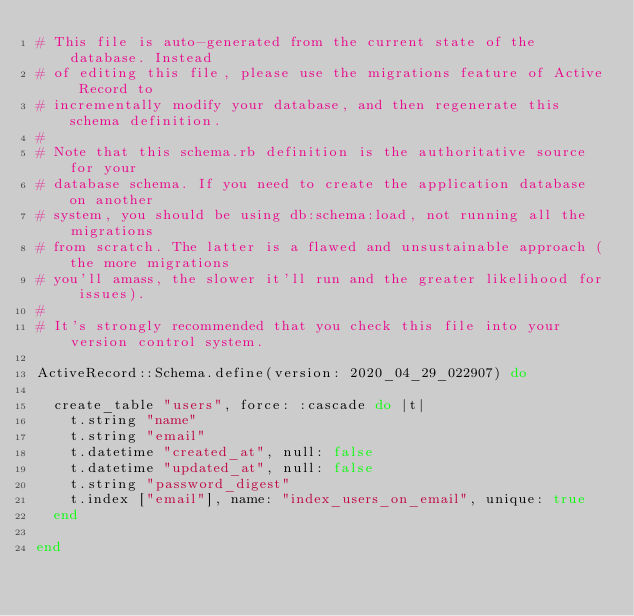Convert code to text. <code><loc_0><loc_0><loc_500><loc_500><_Ruby_># This file is auto-generated from the current state of the database. Instead
# of editing this file, please use the migrations feature of Active Record to
# incrementally modify your database, and then regenerate this schema definition.
#
# Note that this schema.rb definition is the authoritative source for your
# database schema. If you need to create the application database on another
# system, you should be using db:schema:load, not running all the migrations
# from scratch. The latter is a flawed and unsustainable approach (the more migrations
# you'll amass, the slower it'll run and the greater likelihood for issues).
#
# It's strongly recommended that you check this file into your version control system.

ActiveRecord::Schema.define(version: 2020_04_29_022907) do

  create_table "users", force: :cascade do |t|
    t.string "name"
    t.string "email"
    t.datetime "created_at", null: false
    t.datetime "updated_at", null: false
    t.string "password_digest"
    t.index ["email"], name: "index_users_on_email", unique: true
  end

end
</code> 